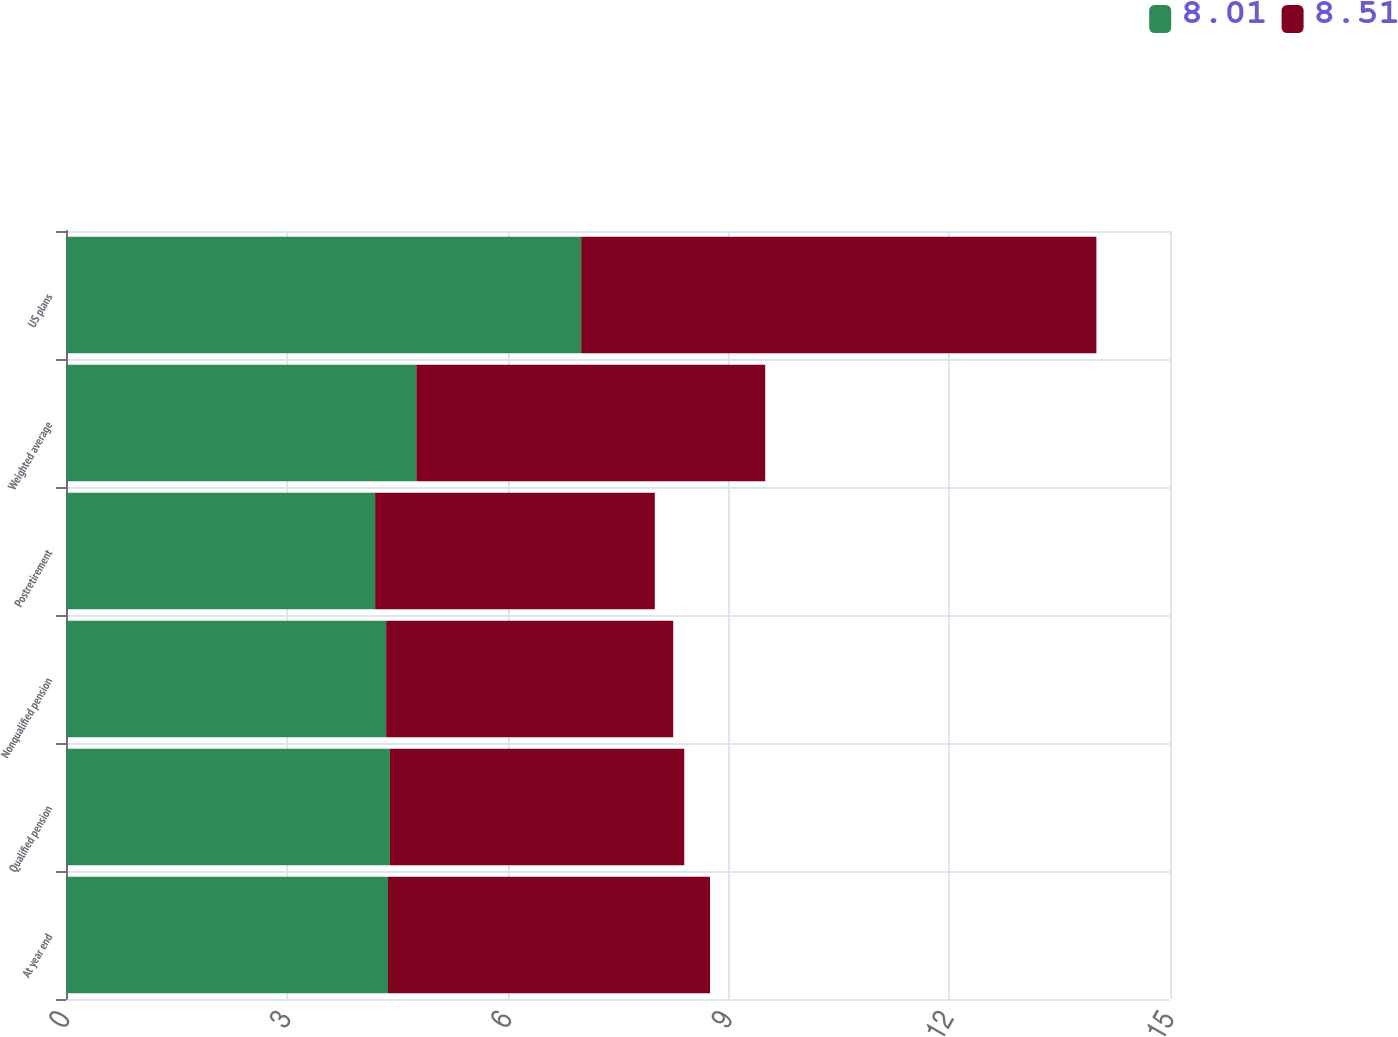<chart> <loc_0><loc_0><loc_500><loc_500><stacked_bar_chart><ecel><fcel>At year end<fcel>Qualified pension<fcel>Nonqualified pension<fcel>Postretirement<fcel>Weighted average<fcel>US plans<nl><fcel>8.01<fcel>4.375<fcel>4.4<fcel>4.35<fcel>4.2<fcel>4.76<fcel>7<nl><fcel>8.51<fcel>4.375<fcel>4<fcel>3.9<fcel>3.8<fcel>4.74<fcel>7<nl></chart> 